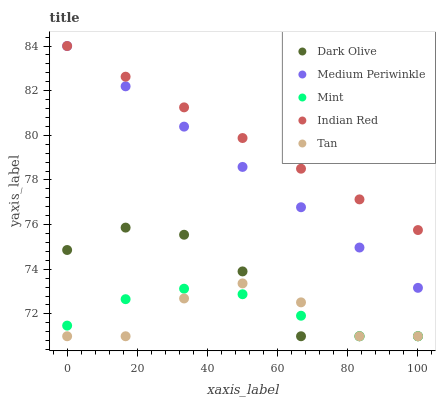Does Tan have the minimum area under the curve?
Answer yes or no. Yes. Does Indian Red have the maximum area under the curve?
Answer yes or no. Yes. Does Dark Olive have the minimum area under the curve?
Answer yes or no. No. Does Dark Olive have the maximum area under the curve?
Answer yes or no. No. Is Indian Red the smoothest?
Answer yes or no. Yes. Is Dark Olive the roughest?
Answer yes or no. Yes. Is Tan the smoothest?
Answer yes or no. No. Is Tan the roughest?
Answer yes or no. No. Does Mint have the lowest value?
Answer yes or no. Yes. Does Medium Periwinkle have the lowest value?
Answer yes or no. No. Does Indian Red have the highest value?
Answer yes or no. Yes. Does Tan have the highest value?
Answer yes or no. No. Is Dark Olive less than Medium Periwinkle?
Answer yes or no. Yes. Is Indian Red greater than Dark Olive?
Answer yes or no. Yes. Does Indian Red intersect Medium Periwinkle?
Answer yes or no. Yes. Is Indian Red less than Medium Periwinkle?
Answer yes or no. No. Is Indian Red greater than Medium Periwinkle?
Answer yes or no. No. Does Dark Olive intersect Medium Periwinkle?
Answer yes or no. No. 